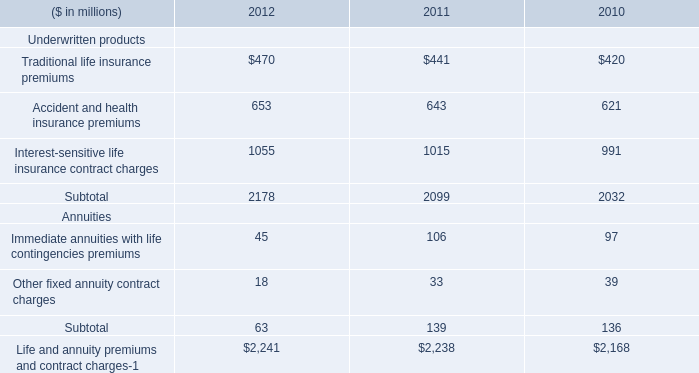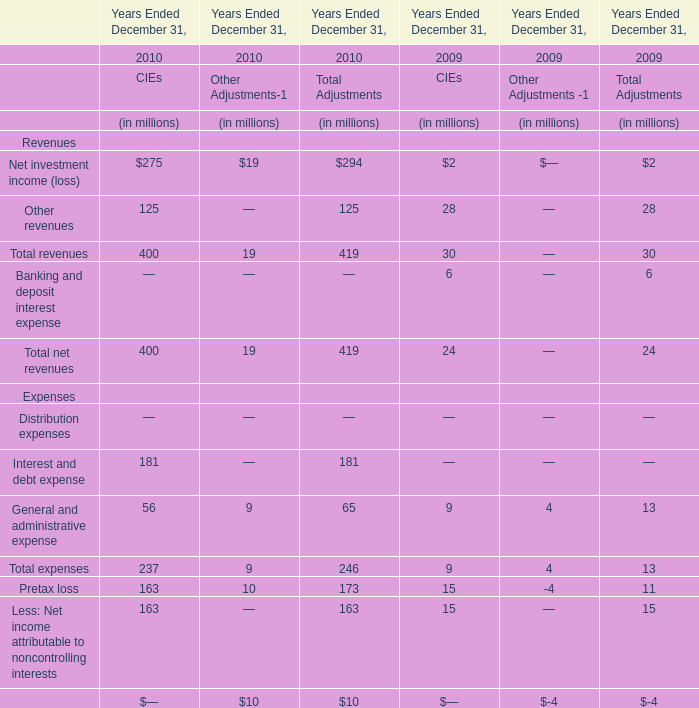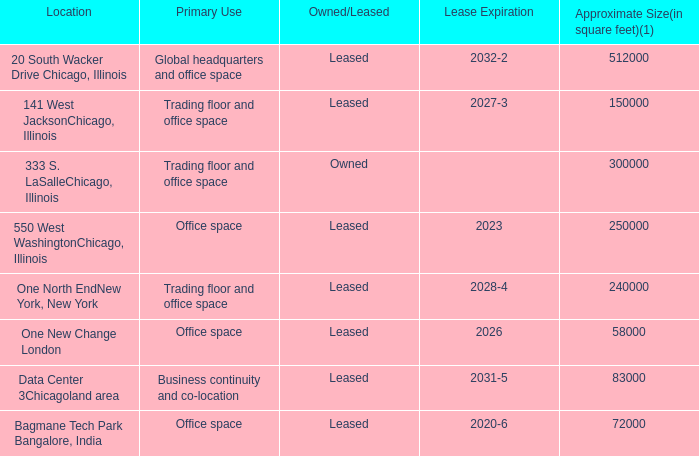by what percentage will the space in one north endnew york new york decrease in 2019? 
Computations: ((225000 - 240000) / 240000)
Answer: -0.0625. 